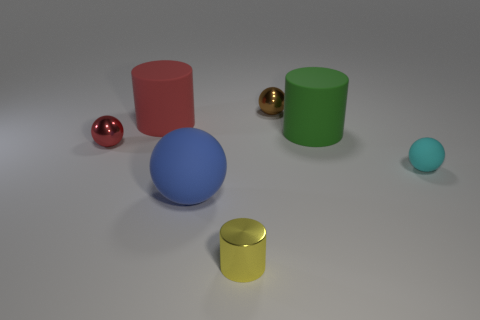There is a matte cylinder left of the rubber ball to the left of the tiny cylinder; how big is it?
Make the answer very short. Large. There is a thing that is to the left of the large matte ball and on the right side of the tiny red sphere; what material is it?
Give a very brief answer. Rubber. There is a brown metallic thing; does it have the same size as the sphere that is in front of the tiny matte thing?
Provide a succinct answer. No. Are any tiny yellow rubber blocks visible?
Ensure brevity in your answer.  No. What material is the large green thing that is the same shape as the yellow shiny object?
Your response must be concise. Rubber. What size is the metallic object left of the large rubber object in front of the big matte cylinder on the right side of the yellow metallic object?
Your response must be concise. Small. Are there any tiny yellow cylinders in front of the small cyan rubber ball?
Make the answer very short. Yes. What is the size of the cyan object that is made of the same material as the green thing?
Ensure brevity in your answer.  Small. What number of red metallic objects are the same shape as the large green thing?
Your response must be concise. 0. Are the large green object and the tiny ball left of the blue rubber ball made of the same material?
Ensure brevity in your answer.  No. 